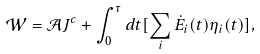<formula> <loc_0><loc_0><loc_500><loc_500>\mathcal { W } = \mathcal { A } J ^ { c } + \int _ { 0 } ^ { \tau } d t [ \sum _ { i } \dot { E } _ { i } ( t ) \eta _ { i } ( t ) ] ,</formula> 